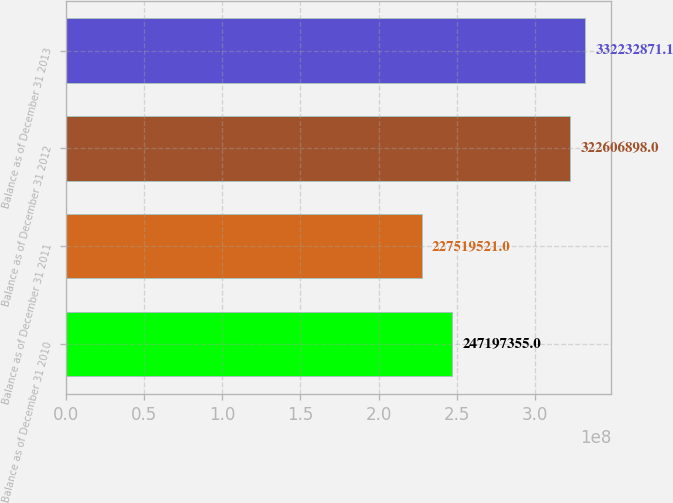<chart> <loc_0><loc_0><loc_500><loc_500><bar_chart><fcel>Balance as of December 31 2010<fcel>Balance as of December 31 2011<fcel>Balance as of December 31 2012<fcel>Balance as of December 31 2013<nl><fcel>2.47197e+08<fcel>2.2752e+08<fcel>3.22607e+08<fcel>3.32233e+08<nl></chart> 